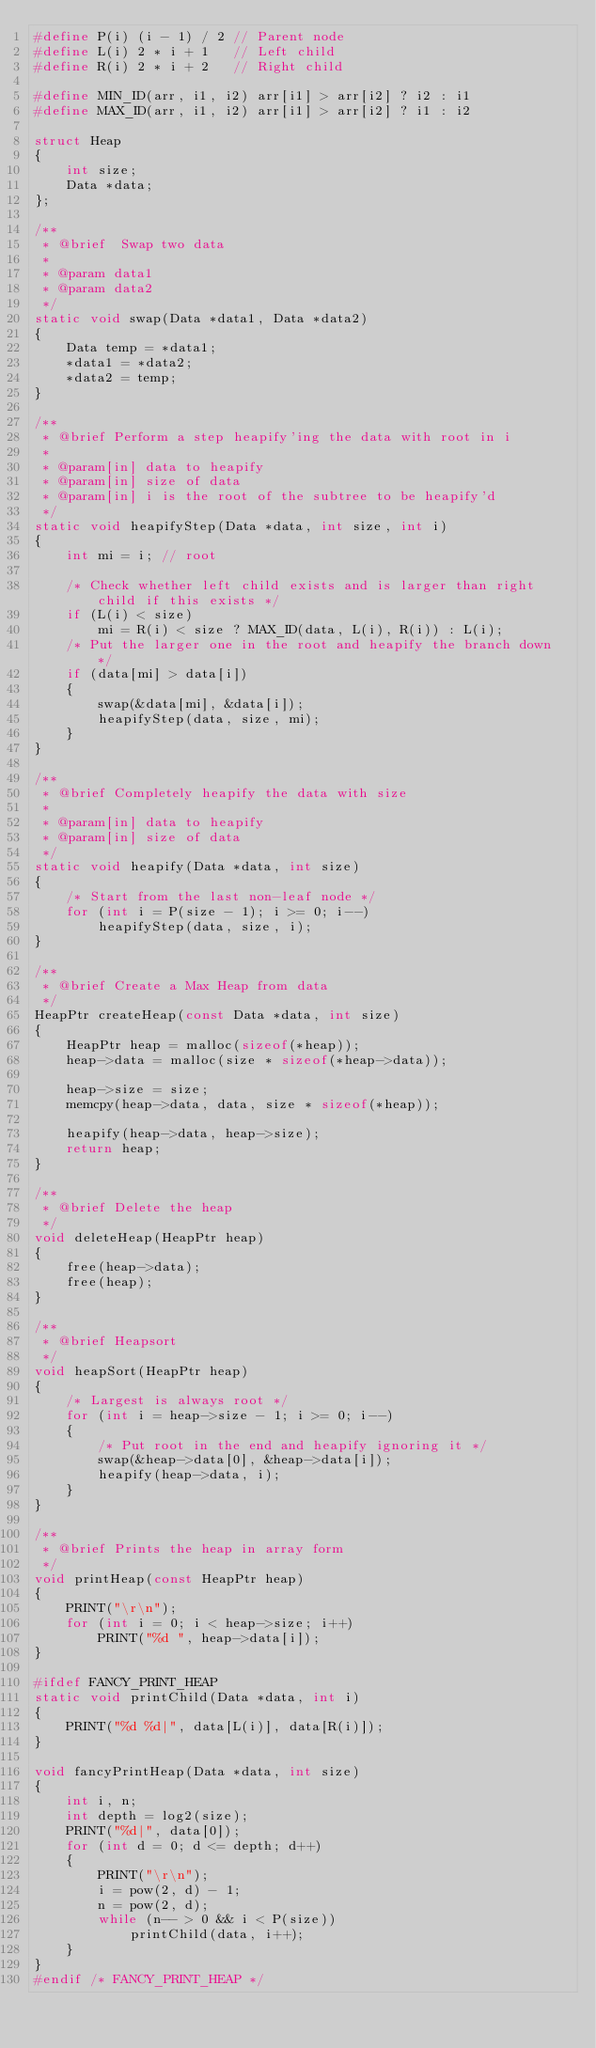Convert code to text. <code><loc_0><loc_0><loc_500><loc_500><_C_>#define P(i) (i - 1) / 2 // Parent node
#define L(i) 2 * i + 1   // Left child
#define R(i) 2 * i + 2   // Right child

#define MIN_ID(arr, i1, i2) arr[i1] > arr[i2] ? i2 : i1
#define MAX_ID(arr, i1, i2) arr[i1] > arr[i2] ? i1 : i2

struct Heap
{
    int size;
    Data *data;
};

/**
 * @brief  Swap two data
 * 
 * @param data1 
 * @param data2 
 */
static void swap(Data *data1, Data *data2)
{
    Data temp = *data1;
    *data1 = *data2;
    *data2 = temp;
}

/**
 * @brief Perform a step heapify'ing the data with root in i
 * 
 * @param[in] data to heapify
 * @param[in] size of data
 * @param[in] i is the root of the subtree to be heapify'd
 */
static void heapifyStep(Data *data, int size, int i)
{
    int mi = i; // root

    /* Check whether left child exists and is larger than right child if this exists */
    if (L(i) < size)
        mi = R(i) < size ? MAX_ID(data, L(i), R(i)) : L(i);
    /* Put the larger one in the root and heapify the branch down */
    if (data[mi] > data[i])
    {
        swap(&data[mi], &data[i]);
        heapifyStep(data, size, mi);
    }
}

/**
 * @brief Completely heapify the data with size
 * 
 * @param[in] data to heapify
 * @param[in] size of data
 */
static void heapify(Data *data, int size)
{
    /* Start from the last non-leaf node */
    for (int i = P(size - 1); i >= 0; i--)
        heapifyStep(data, size, i);
}

/**
 * @brief Create a Max Heap from data
 */
HeapPtr createHeap(const Data *data, int size)
{
    HeapPtr heap = malloc(sizeof(*heap));
    heap->data = malloc(size * sizeof(*heap->data));

    heap->size = size;
    memcpy(heap->data, data, size * sizeof(*heap));

    heapify(heap->data, heap->size);
    return heap;
}

/**
 * @brief Delete the heap
 */
void deleteHeap(HeapPtr heap)
{
    free(heap->data);
    free(heap);
}

/**
 * @brief Heapsort
 */
void heapSort(HeapPtr heap)
{
    /* Largest is always root */
    for (int i = heap->size - 1; i >= 0; i--)
    {
        /* Put root in the end and heapify ignoring it */
        swap(&heap->data[0], &heap->data[i]);
        heapify(heap->data, i);
    }
}

/**
 * @brief Prints the heap in array form
 */
void printHeap(const HeapPtr heap)
{
    PRINT("\r\n");
    for (int i = 0; i < heap->size; i++)
        PRINT("%d ", heap->data[i]);
}

#ifdef FANCY_PRINT_HEAP
static void printChild(Data *data, int i)
{
    PRINT("%d %d|", data[L(i)], data[R(i)]);
}

void fancyPrintHeap(Data *data, int size)
{
    int i, n;
    int depth = log2(size);
    PRINT("%d|", data[0]);
    for (int d = 0; d <= depth; d++)
    {
        PRINT("\r\n");
        i = pow(2, d) - 1;
        n = pow(2, d);
        while (n-- > 0 && i < P(size))
            printChild(data, i++);
    }
}
#endif /* FANCY_PRINT_HEAP */
</code> 